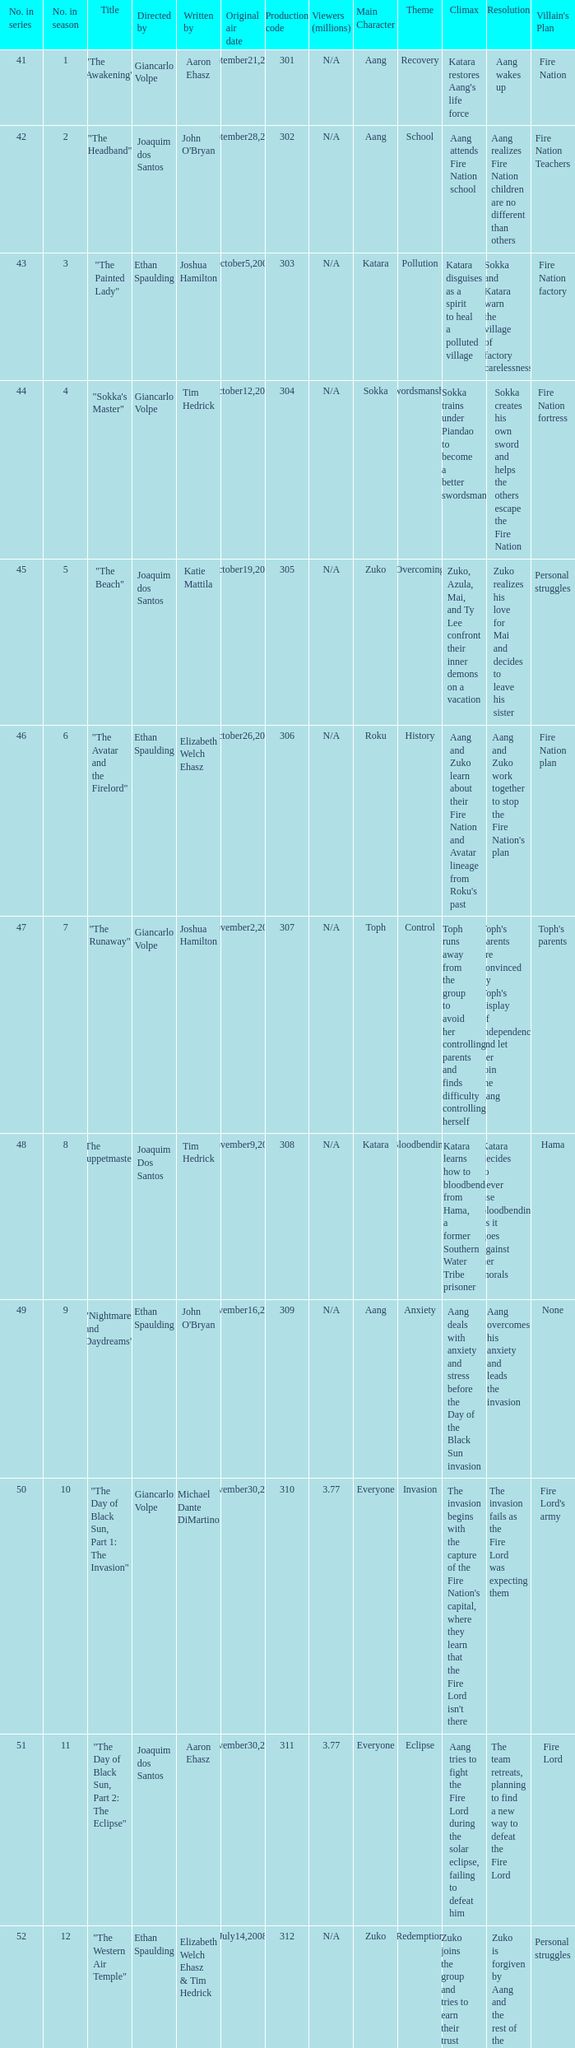What is the original air date for the episode with a production code of 318? July19,2008. 